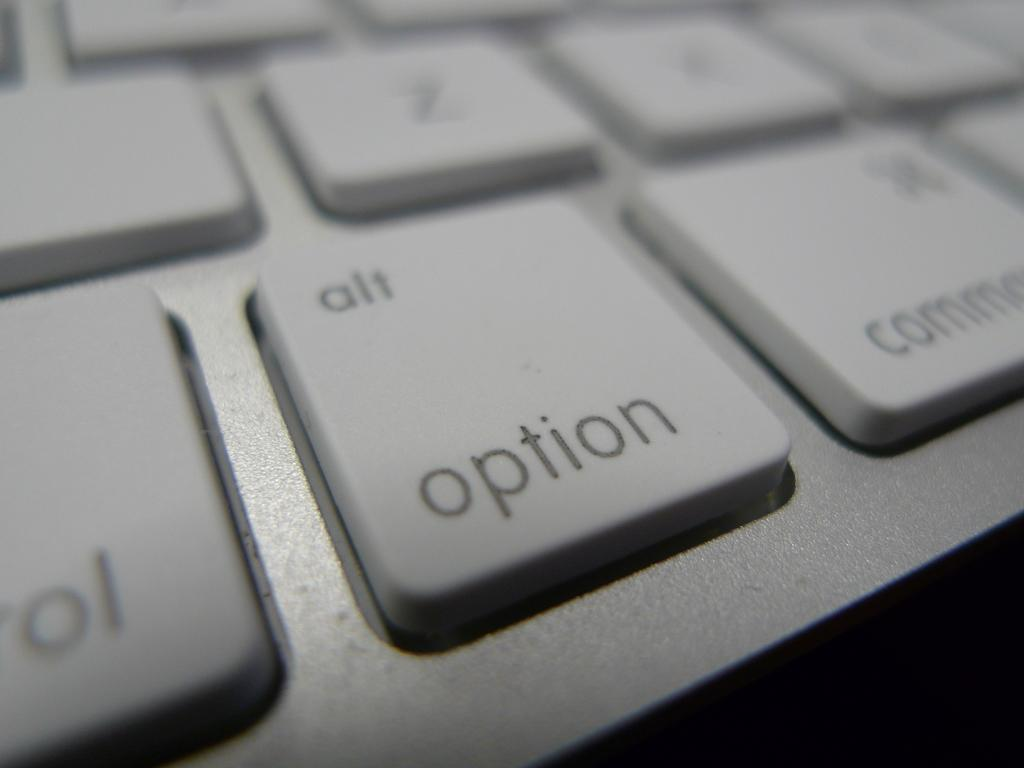<image>
Render a clear and concise summary of the photo. Keyboard showing an Option button with the alt key on the same button. 